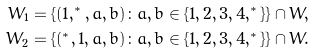Convert formula to latex. <formula><loc_0><loc_0><loc_500><loc_500>W _ { 1 } & = \{ ( 1 , ^ { * } , a , b ) \colon a , b \in \{ 1 , 2 , 3 , 4 , ^ { * } \} \} \cap W , \\ W _ { 2 } & = \{ ( ^ { * } , 1 , a , b ) \colon a , b \in \{ 1 , 2 , 3 , 4 , ^ { * } \} \} \cap W .</formula> 